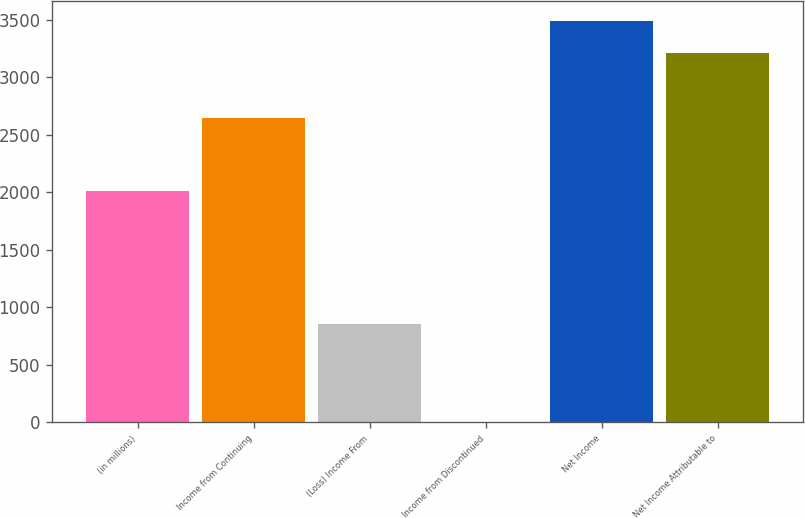Convert chart. <chart><loc_0><loc_0><loc_500><loc_500><bar_chart><fcel>(in millions)<fcel>Income from Continuing<fcel>(Loss) Income From<fcel>Income from Discontinued<fcel>Net Income<fcel>Net Income Attributable to<nl><fcel>2015<fcel>2645<fcel>853.5<fcel>6<fcel>3492.5<fcel>3210<nl></chart> 